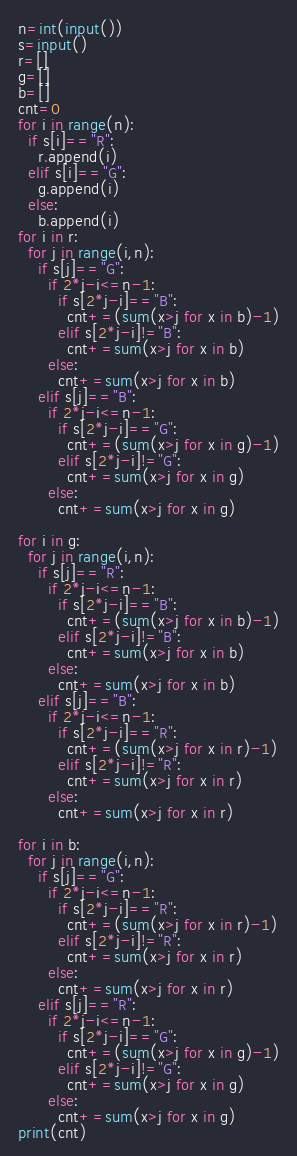Convert code to text. <code><loc_0><loc_0><loc_500><loc_500><_Python_>n=int(input())
s=input()
r=[]
g=[]
b=[]
cnt=0
for i in range(n):
  if s[i]=="R":
    r.append(i)
  elif s[i]=="G":
    g.append(i)
  else:
    b.append(i)
for i in r:
  for j in range(i,n):
    if s[j]=="G":
      if 2*j-i<=n-1:
        if s[2*j-i]=="B":
          cnt+=(sum(x>j for x in b)-1)
        elif s[2*j-i]!="B":
          cnt+=sum(x>j for x in b)
      else:
        cnt+=sum(x>j for x in b)
    elif s[j]=="B":
      if 2*j-i<=n-1:
        if s[2*j-i]=="G":
          cnt+=(sum(x>j for x in g)-1)
        elif s[2*j-i]!="G":
          cnt+=sum(x>j for x in g)
      else:
        cnt+=sum(x>j for x in g)

for i in g:
  for j in range(i,n):
    if s[j]=="R":
      if 2*j-i<=n-1:
        if s[2*j-i]=="B":
          cnt+=(sum(x>j for x in b)-1)
        elif s[2*j-i]!="B":
          cnt+=sum(x>j for x in b)
      else:
        cnt+=sum(x>j for x in b)
    elif s[j]=="B":
      if 2*j-i<=n-1:
        if s[2*j-i]=="R":
          cnt+=(sum(x>j for x in r)-1)
        elif s[2*j-i]!="R":
          cnt+=sum(x>j for x in r)
      else:
        cnt+=sum(x>j for x in r)

for i in b:
  for j in range(i,n):
    if s[j]=="G":
      if 2*j-i<=n-1:
        if s[2*j-i]=="R":
          cnt+=(sum(x>j for x in r)-1)
        elif s[2*j-i]!="R":
          cnt+=sum(x>j for x in r)
      else:
        cnt+=sum(x>j for x in r)
    elif s[j]=="R":
      if 2*j-i<=n-1:
        if s[2*j-i]=="G":
          cnt+=(sum(x>j for x in g)-1)
        elif s[2*j-i]!="G":
          cnt+=sum(x>j for x in g)
      else:
        cnt+=sum(x>j for x in g)
print(cnt)</code> 